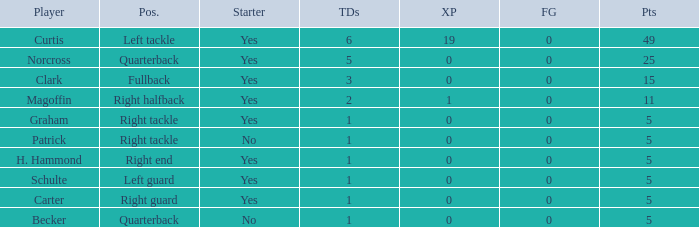Name the most touchdowns for becker  1.0. 